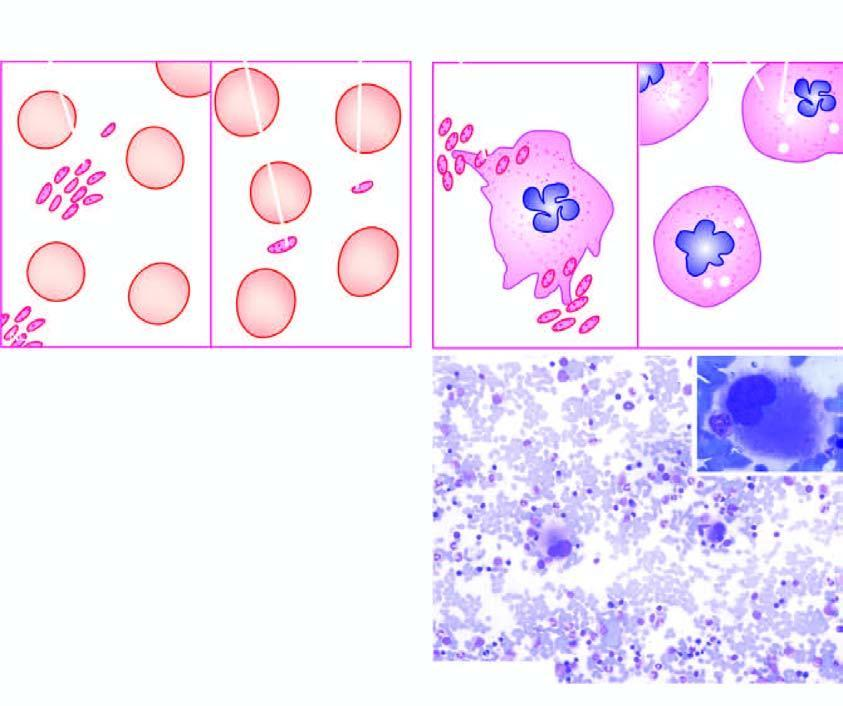does ideroblastic anaemia bone marrow show presence of reduced number of platelets which are often large?
Answer the question using a single word or phrase. No 